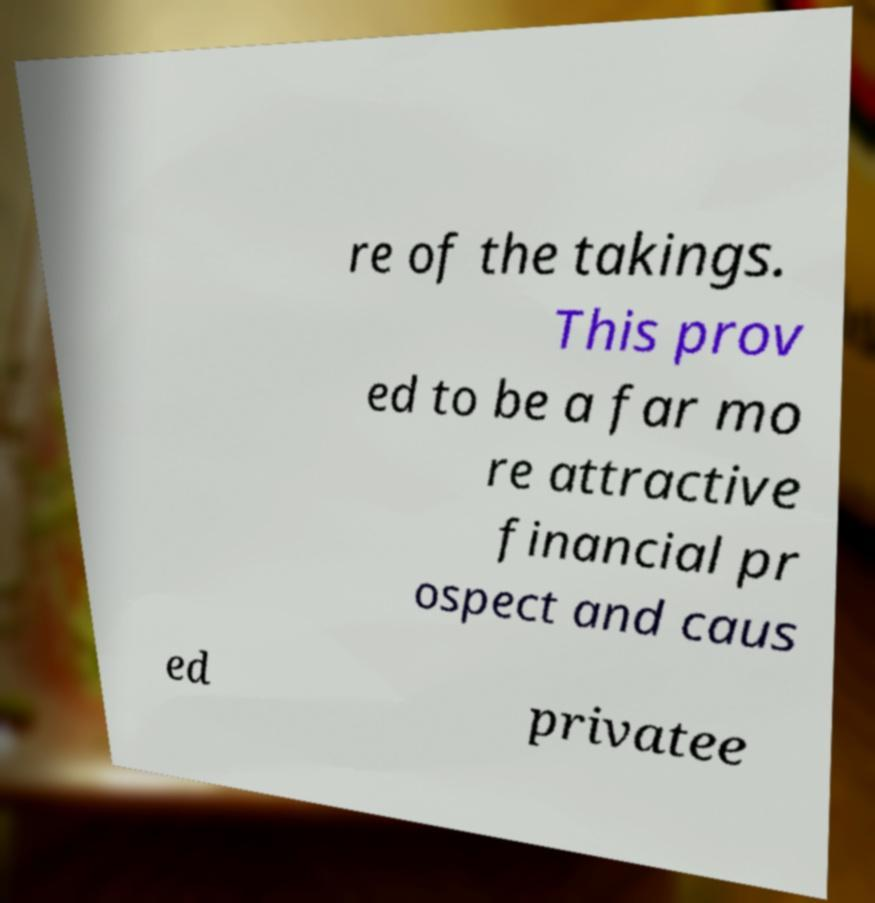Please identify and transcribe the text found in this image. re of the takings. This prov ed to be a far mo re attractive financial pr ospect and caus ed privatee 